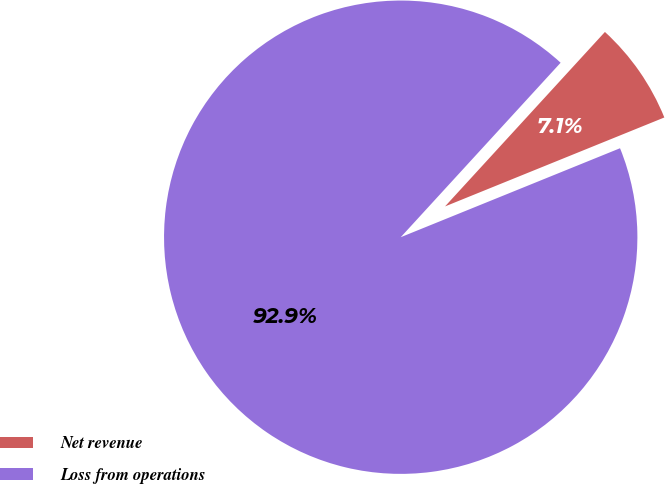<chart> <loc_0><loc_0><loc_500><loc_500><pie_chart><fcel>Net revenue<fcel>Loss from operations<nl><fcel>7.06%<fcel>92.94%<nl></chart> 